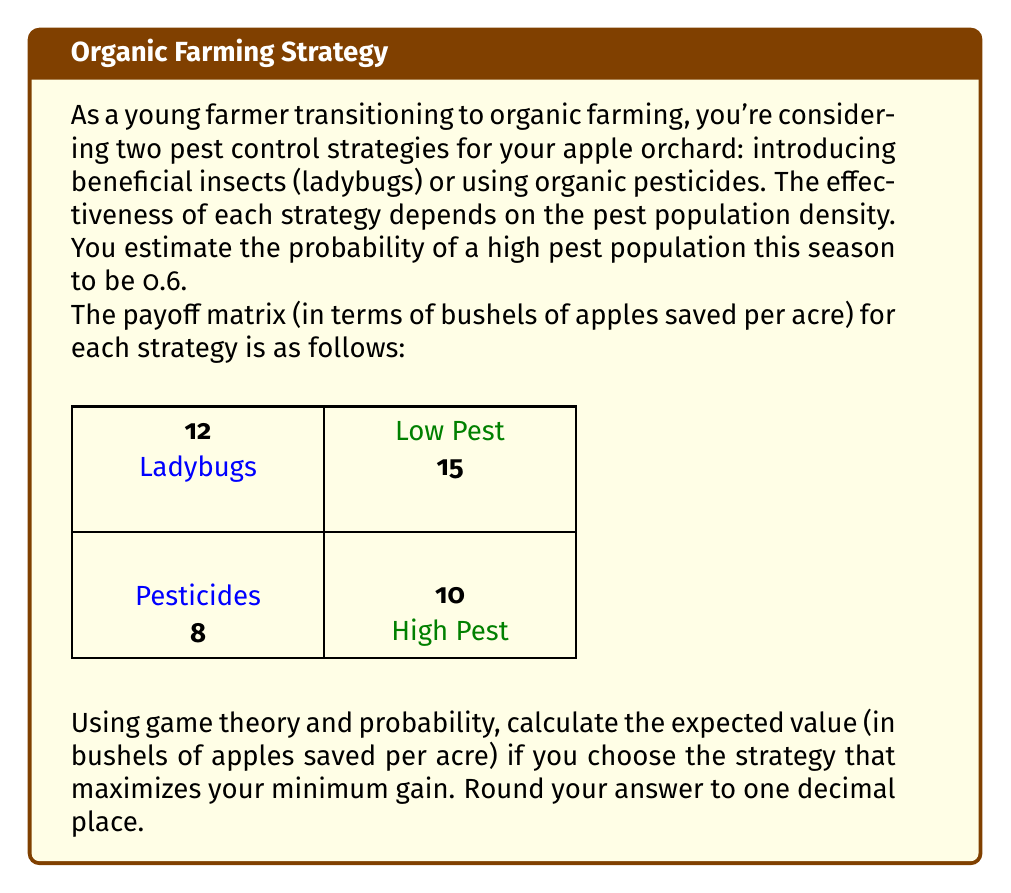Solve this math problem. Let's approach this step-by-step:

1) First, we need to understand the concept of maximizing the minimum gain, also known as the maximin strategy. This strategy chooses the option that provides the best outcome in the worst-case scenario.

2) For ladybugs:
   - If pest population is low: 12 bushels
   - If pest population is high: 8 bushels
   Minimum gain: 8 bushels

3) For pesticides:
   - If pest population is low: 15 bushels
   - If pest population is high: 10 bushels
   Minimum gain: 10 bushels

4) The maximin strategy is to choose pesticides, as it guarantees a minimum of 10 bushels saved, compared to 8 bushels for ladybugs.

5) Now, we need to calculate the expected value of this strategy using the given probability:

   Let $p$ be the probability of high pest population (0.6)
   Let $E$ be the expected value

   $$E = p \cdot (\text{payoff for high pest}) + (1-p) \cdot (\text{payoff for low pest})$$
   $$E = 0.6 \cdot 10 + 0.4 \cdot 15$$
   $$E = 6 + 6 = 12$$

6) Therefore, the expected value is 12 bushels of apples saved per acre.
Answer: 12.0 bushels 